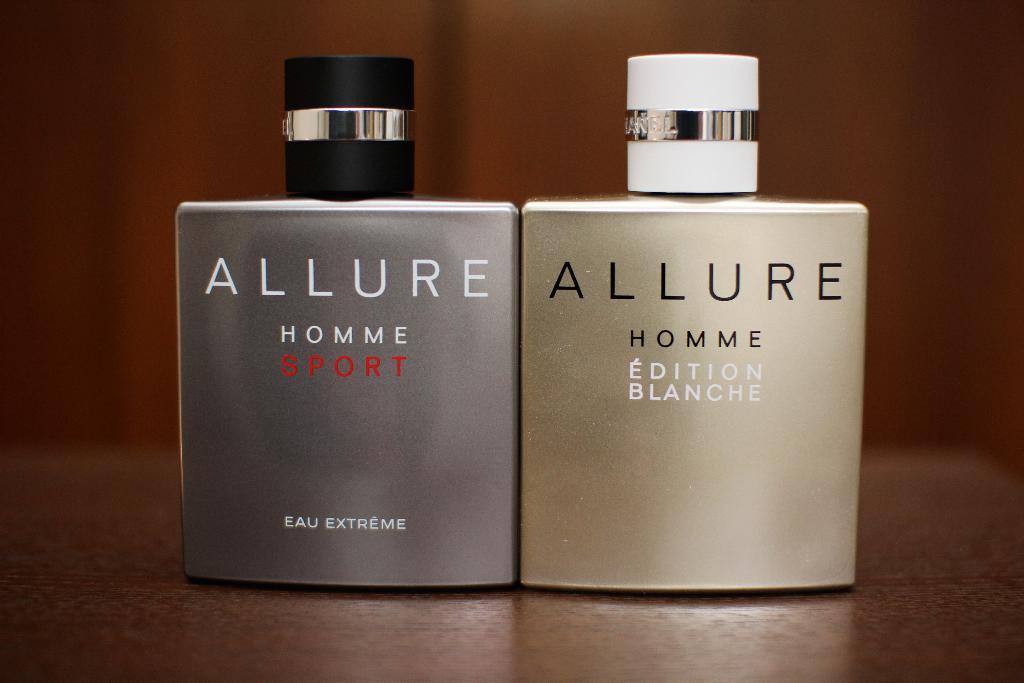What's the ladies version of this perfume called?
Your answer should be compact. Edition blanche. What is one type of this men's cologne?
Make the answer very short. Sport. 